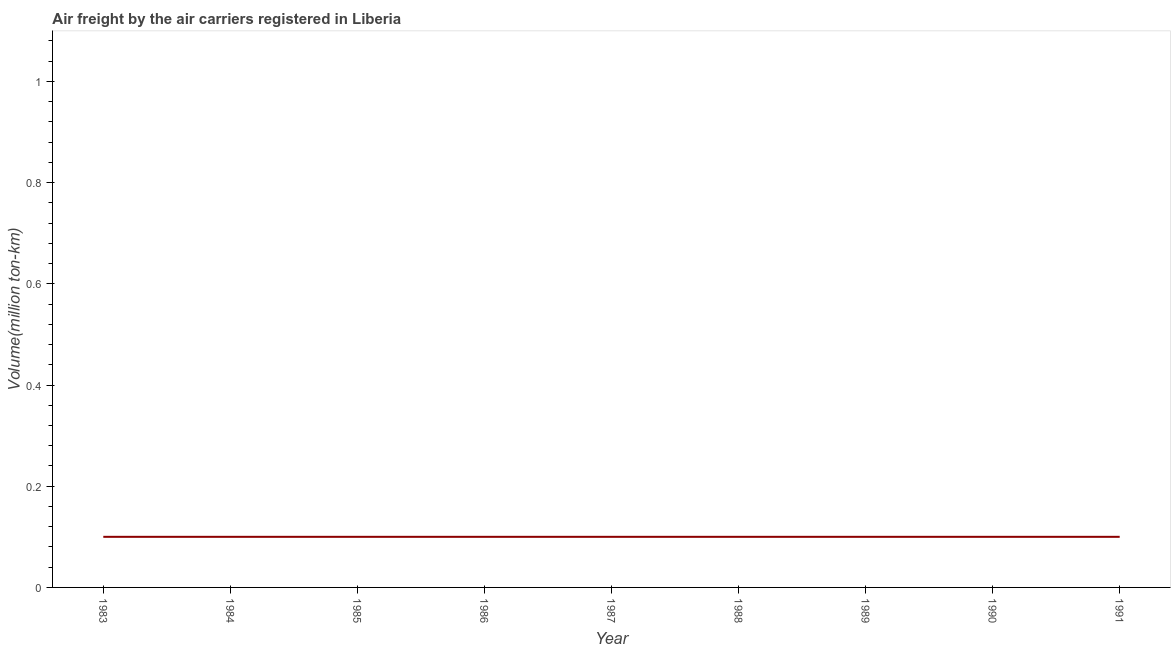What is the air freight in 1983?
Your response must be concise. 0.1. Across all years, what is the maximum air freight?
Provide a short and direct response. 0.1. Across all years, what is the minimum air freight?
Offer a terse response. 0.1. In which year was the air freight maximum?
Offer a terse response. 1983. In which year was the air freight minimum?
Make the answer very short. 1983. What is the sum of the air freight?
Keep it short and to the point. 0.9. What is the difference between the air freight in 1984 and 1989?
Offer a very short reply. 0. What is the average air freight per year?
Offer a terse response. 0.1. What is the median air freight?
Provide a short and direct response. 0.1. Do a majority of the years between 1986 and 1989 (inclusive) have air freight greater than 0.52 million ton-km?
Your answer should be very brief. No. Is the air freight in 1984 less than that in 1988?
Keep it short and to the point. No. Is the sum of the air freight in 1990 and 1991 greater than the maximum air freight across all years?
Your answer should be compact. Yes. In how many years, is the air freight greater than the average air freight taken over all years?
Provide a succinct answer. 0. Does the air freight monotonically increase over the years?
Offer a very short reply. No. Are the values on the major ticks of Y-axis written in scientific E-notation?
Make the answer very short. No. Does the graph contain any zero values?
Give a very brief answer. No. What is the title of the graph?
Ensure brevity in your answer.  Air freight by the air carriers registered in Liberia. What is the label or title of the X-axis?
Offer a very short reply. Year. What is the label or title of the Y-axis?
Ensure brevity in your answer.  Volume(million ton-km). What is the Volume(million ton-km) of 1983?
Give a very brief answer. 0.1. What is the Volume(million ton-km) of 1984?
Offer a terse response. 0.1. What is the Volume(million ton-km) of 1985?
Provide a succinct answer. 0.1. What is the Volume(million ton-km) of 1986?
Make the answer very short. 0.1. What is the Volume(million ton-km) in 1987?
Offer a very short reply. 0.1. What is the Volume(million ton-km) of 1988?
Ensure brevity in your answer.  0.1. What is the Volume(million ton-km) of 1989?
Provide a short and direct response. 0.1. What is the Volume(million ton-km) of 1990?
Provide a short and direct response. 0.1. What is the Volume(million ton-km) in 1991?
Offer a very short reply. 0.1. What is the difference between the Volume(million ton-km) in 1983 and 1986?
Your answer should be very brief. 0. What is the difference between the Volume(million ton-km) in 1983 and 1987?
Offer a terse response. 0. What is the difference between the Volume(million ton-km) in 1983 and 1989?
Provide a succinct answer. 0. What is the difference between the Volume(million ton-km) in 1983 and 1990?
Keep it short and to the point. 0. What is the difference between the Volume(million ton-km) in 1984 and 1986?
Offer a terse response. 0. What is the difference between the Volume(million ton-km) in 1984 and 1990?
Your response must be concise. 0. What is the difference between the Volume(million ton-km) in 1984 and 1991?
Give a very brief answer. 0. What is the difference between the Volume(million ton-km) in 1985 and 1986?
Your answer should be compact. 0. What is the difference between the Volume(million ton-km) in 1985 and 1988?
Your answer should be very brief. 0. What is the difference between the Volume(million ton-km) in 1986 and 1988?
Ensure brevity in your answer.  0. What is the difference between the Volume(million ton-km) in 1986 and 1989?
Offer a terse response. 0. What is the difference between the Volume(million ton-km) in 1986 and 1990?
Keep it short and to the point. 0. What is the difference between the Volume(million ton-km) in 1987 and 1989?
Ensure brevity in your answer.  0. What is the difference between the Volume(million ton-km) in 1987 and 1991?
Your response must be concise. 0. What is the difference between the Volume(million ton-km) in 1989 and 1990?
Provide a short and direct response. 0. What is the difference between the Volume(million ton-km) in 1989 and 1991?
Offer a terse response. 0. What is the ratio of the Volume(million ton-km) in 1983 to that in 1985?
Keep it short and to the point. 1. What is the ratio of the Volume(million ton-km) in 1983 to that in 1988?
Your answer should be very brief. 1. What is the ratio of the Volume(million ton-km) in 1983 to that in 1990?
Your answer should be compact. 1. What is the ratio of the Volume(million ton-km) in 1984 to that in 1986?
Keep it short and to the point. 1. What is the ratio of the Volume(million ton-km) in 1984 to that in 1987?
Provide a short and direct response. 1. What is the ratio of the Volume(million ton-km) in 1984 to that in 1988?
Your answer should be compact. 1. What is the ratio of the Volume(million ton-km) in 1984 to that in 1989?
Keep it short and to the point. 1. What is the ratio of the Volume(million ton-km) in 1985 to that in 1987?
Give a very brief answer. 1. What is the ratio of the Volume(million ton-km) in 1985 to that in 1989?
Ensure brevity in your answer.  1. What is the ratio of the Volume(million ton-km) in 1985 to that in 1991?
Offer a terse response. 1. What is the ratio of the Volume(million ton-km) in 1986 to that in 1990?
Ensure brevity in your answer.  1. What is the ratio of the Volume(million ton-km) in 1986 to that in 1991?
Your answer should be very brief. 1. What is the ratio of the Volume(million ton-km) in 1987 to that in 1990?
Provide a succinct answer. 1. What is the ratio of the Volume(million ton-km) in 1987 to that in 1991?
Make the answer very short. 1. What is the ratio of the Volume(million ton-km) in 1988 to that in 1989?
Keep it short and to the point. 1. What is the ratio of the Volume(million ton-km) in 1988 to that in 1990?
Give a very brief answer. 1. What is the ratio of the Volume(million ton-km) in 1988 to that in 1991?
Your answer should be very brief. 1. What is the ratio of the Volume(million ton-km) in 1989 to that in 1990?
Keep it short and to the point. 1. What is the ratio of the Volume(million ton-km) in 1990 to that in 1991?
Your response must be concise. 1. 